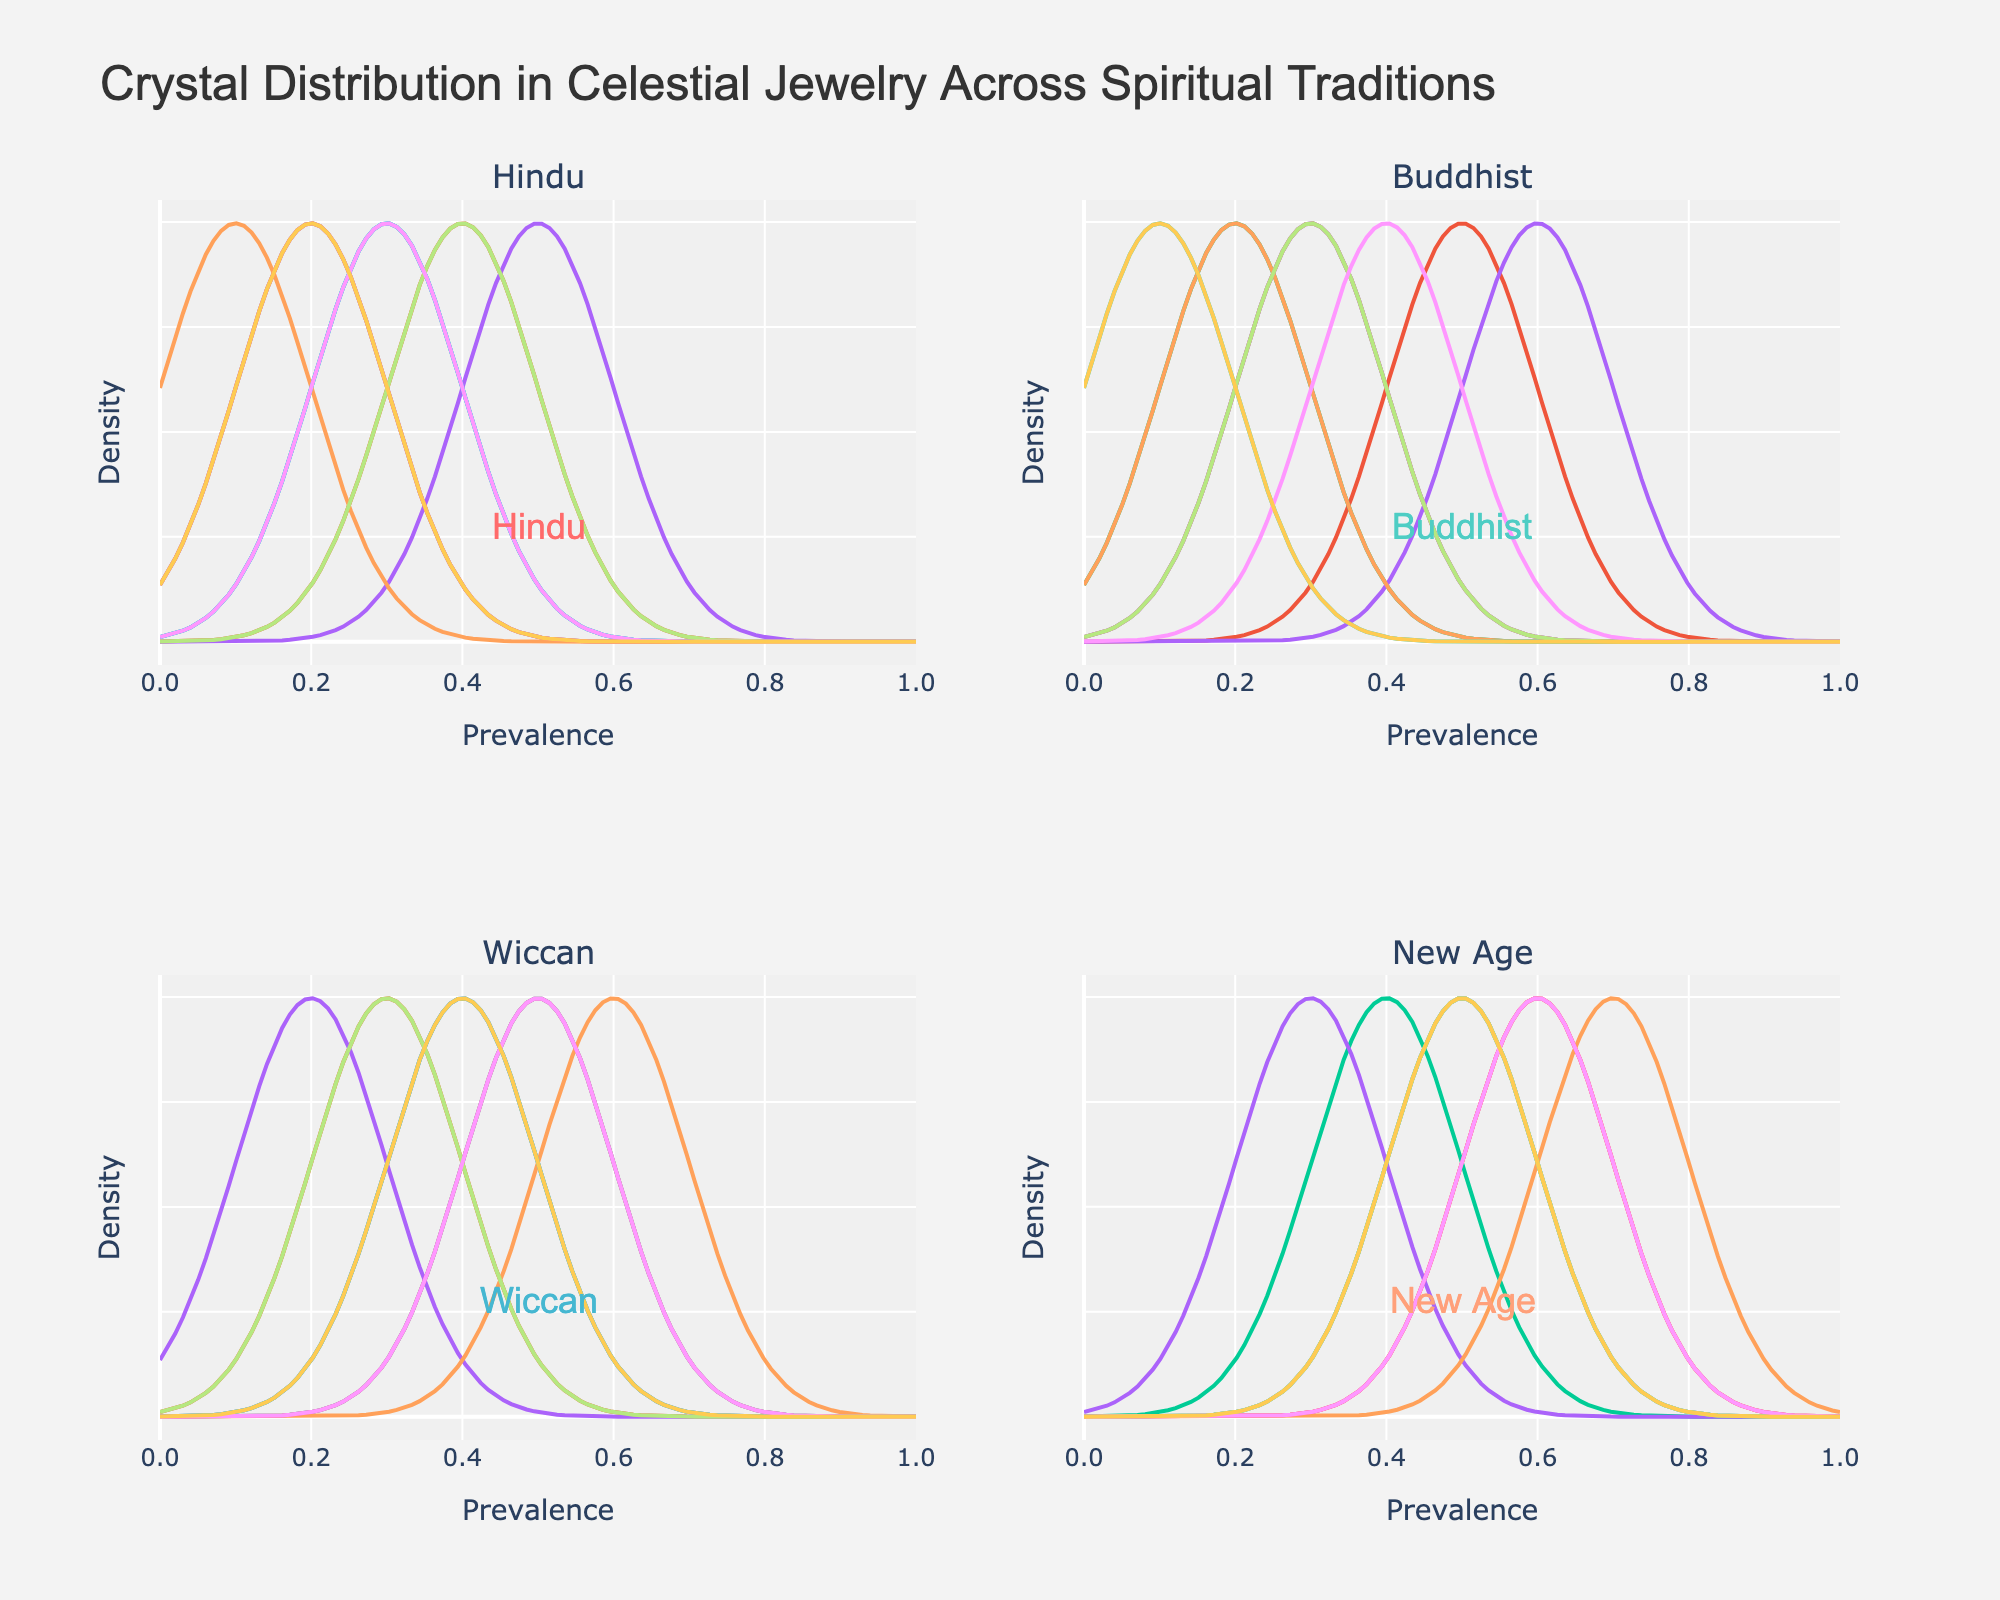What is the title of this figure? The title of the figure is clearly written at the top of the plot, which indicates the main topic of the visualization.
Answer: "Crystal Distribution in Celestial Jewelry Across Spiritual Traditions" Which spiritual tradition uses the most Lapis Lazuli? By examining the density plots for each spiritual tradition, the peak of the distribution curve for Lapis Lazuli is highest in the subplot labeled "Buddhist".
Answer: Buddhist Which crystal type has the highest prevalence in the New Age tradition? By looking at the subplot for New Age, the crystal type with the highest peak indicates the highest prevalence. The peak of the density plot for Selenite is the highest.
Answer: Selenite Between Hindu and Wiccan traditions, which one has a higher prevalence of Moonstone? By comparing the density plots for Moonstone in both the Hindu and Wiccan subplots, Wiccan has the higher peak indicating a higher prevalence.
Answer: Wiccan Which spiritual tradition shows a similar distribution pattern for Amethyst and Rose Quartz? By visual inspection, the subplot for New Age shows that the density plots for Amethyst and Rose Quartz both have peaks around 0.5, indicating similar distribution patterns.
Answer: New Age For which crystal type are the prevalence distributions more evenly spread across traditions? By examining all subplots, Quartz shows a more even peak across the different traditions compared to other crystals.
Answer: Quartz Is Selenite more prevalent in Hindu or New Age tradition? The density plot for Selenite in the New Age tradition shows a higher peak compared to the Hindu tradition, indicating higher prevalence.
Answer: New Age Which crystal type appears to be less relevant in the Wiccan tradition compared to others? By examining the peaks in the Wiccan subplot, Lapis Lazuli shows a lower peak compared to the other crystals, indicating lower relevance.
Answer: Lapis Lazuli What is the common prevalence range for Citrine across different traditions? By looking at the peaks of the density plots for Citrine in each subplot, the common prevalence range appears to be around 0.3 to 0.5.
Answer: 0.3 to 0.5 